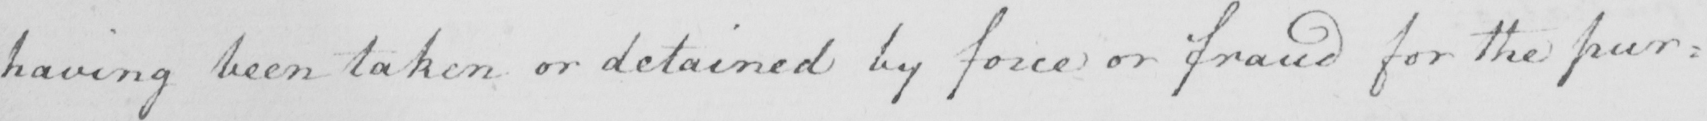What text is written in this handwritten line? having been taken or detained by force or fraud for the pur= 